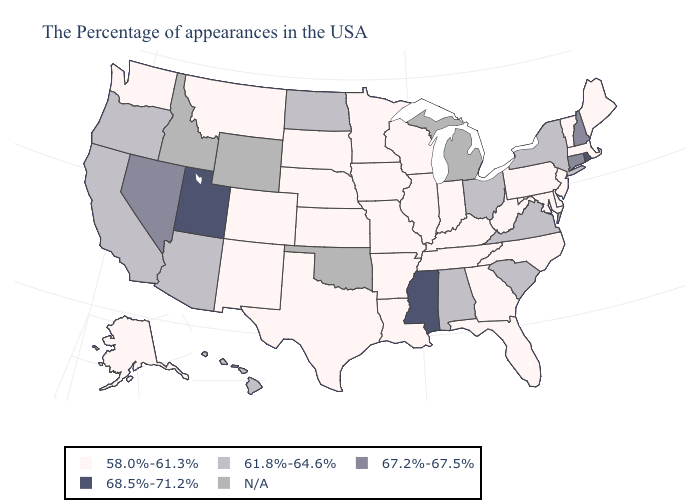What is the highest value in the USA?
Short answer required. 68.5%-71.2%. What is the value of California?
Answer briefly. 61.8%-64.6%. Does Connecticut have the lowest value in the Northeast?
Be succinct. No. What is the highest value in the Northeast ?
Be succinct. 68.5%-71.2%. Among the states that border Connecticut , does Rhode Island have the lowest value?
Quick response, please. No. What is the highest value in the USA?
Be succinct. 68.5%-71.2%. What is the value of Massachusetts?
Write a very short answer. 58.0%-61.3%. Name the states that have a value in the range 58.0%-61.3%?
Be succinct. Maine, Massachusetts, Vermont, New Jersey, Delaware, Maryland, Pennsylvania, North Carolina, West Virginia, Florida, Georgia, Kentucky, Indiana, Tennessee, Wisconsin, Illinois, Louisiana, Missouri, Arkansas, Minnesota, Iowa, Kansas, Nebraska, Texas, South Dakota, Colorado, New Mexico, Montana, Washington, Alaska. What is the value of Georgia?
Concise answer only. 58.0%-61.3%. Does Hawaii have the lowest value in the West?
Be succinct. No. What is the value of New York?
Quick response, please. 61.8%-64.6%. What is the value of Michigan?
Quick response, please. N/A. What is the value of South Carolina?
Be succinct. 61.8%-64.6%. What is the value of Missouri?
Give a very brief answer. 58.0%-61.3%. 